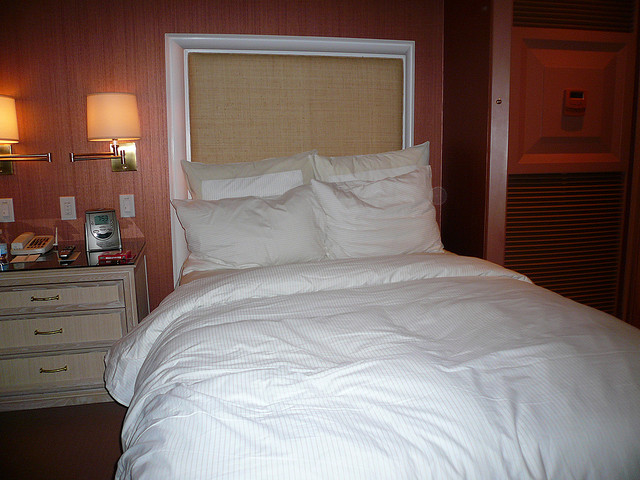<image>Is the bedspread patterned? It is ambiguous whether the bedspread is patterned or not. Is the bedspread patterned? I am not sure if the bedspread is patterned. It can be both patterned and plain. 